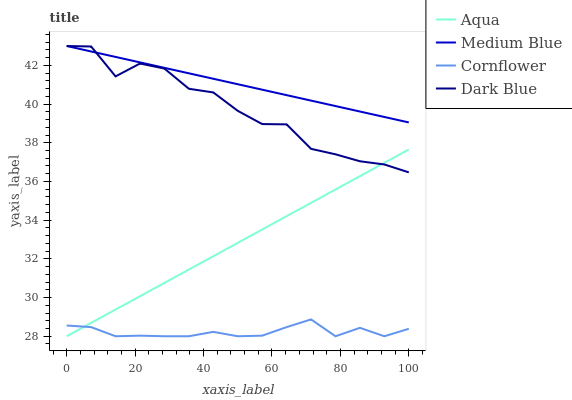Does Cornflower have the minimum area under the curve?
Answer yes or no. Yes. Does Medium Blue have the maximum area under the curve?
Answer yes or no. Yes. Does Aqua have the minimum area under the curve?
Answer yes or no. No. Does Aqua have the maximum area under the curve?
Answer yes or no. No. Is Medium Blue the smoothest?
Answer yes or no. Yes. Is Dark Blue the roughest?
Answer yes or no. Yes. Is Aqua the smoothest?
Answer yes or no. No. Is Aqua the roughest?
Answer yes or no. No. Does Aqua have the lowest value?
Answer yes or no. Yes. Does Dark Blue have the lowest value?
Answer yes or no. No. Does Dark Blue have the highest value?
Answer yes or no. Yes. Does Aqua have the highest value?
Answer yes or no. No. Is Aqua less than Medium Blue?
Answer yes or no. Yes. Is Dark Blue greater than Cornflower?
Answer yes or no. Yes. Does Aqua intersect Dark Blue?
Answer yes or no. Yes. Is Aqua less than Dark Blue?
Answer yes or no. No. Is Aqua greater than Dark Blue?
Answer yes or no. No. Does Aqua intersect Medium Blue?
Answer yes or no. No. 